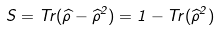<formula> <loc_0><loc_0><loc_500><loc_500>S = T r ( \widehat { \rho } - \widehat { \rho } ^ { 2 } ) = 1 - T r ( \widehat { \rho } ^ { 2 } )</formula> 